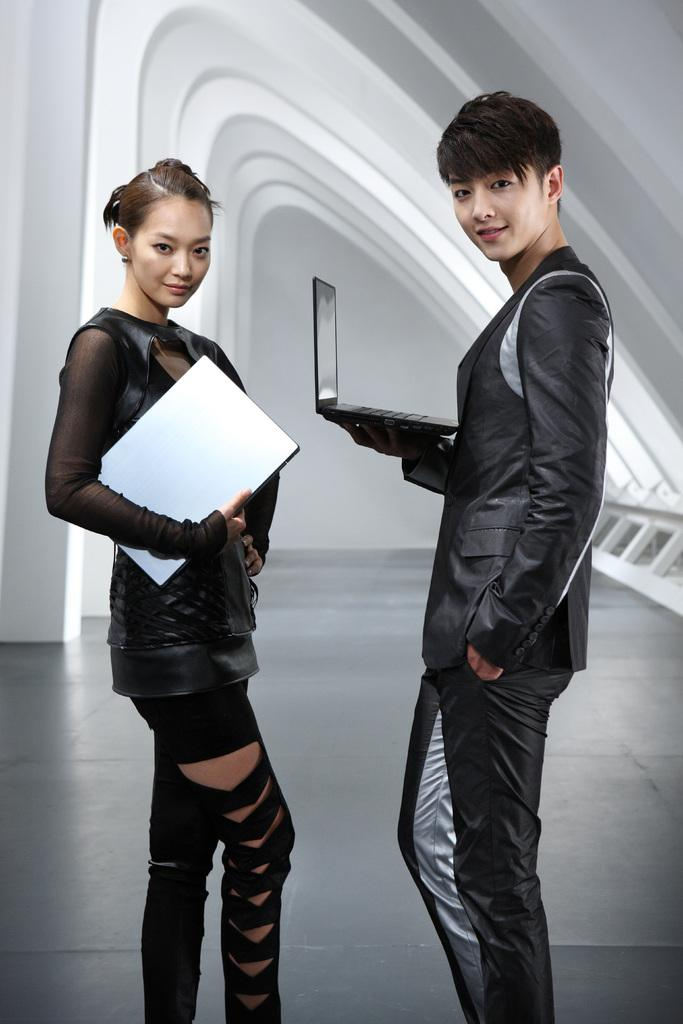How many people are present in the image? There are two people in the image, a woman and a man. What are the positions of the woman and the man in the image? Both the woman and the man are standing on the floor. What can be seen in the background of the image? There is a wall in the background of the image. What type of cable can be seen hanging from the ceiling in the image? There is no cable hanging from the ceiling in the image. How many eggs are visible on the floor in the image? There are no eggs present in the image. 